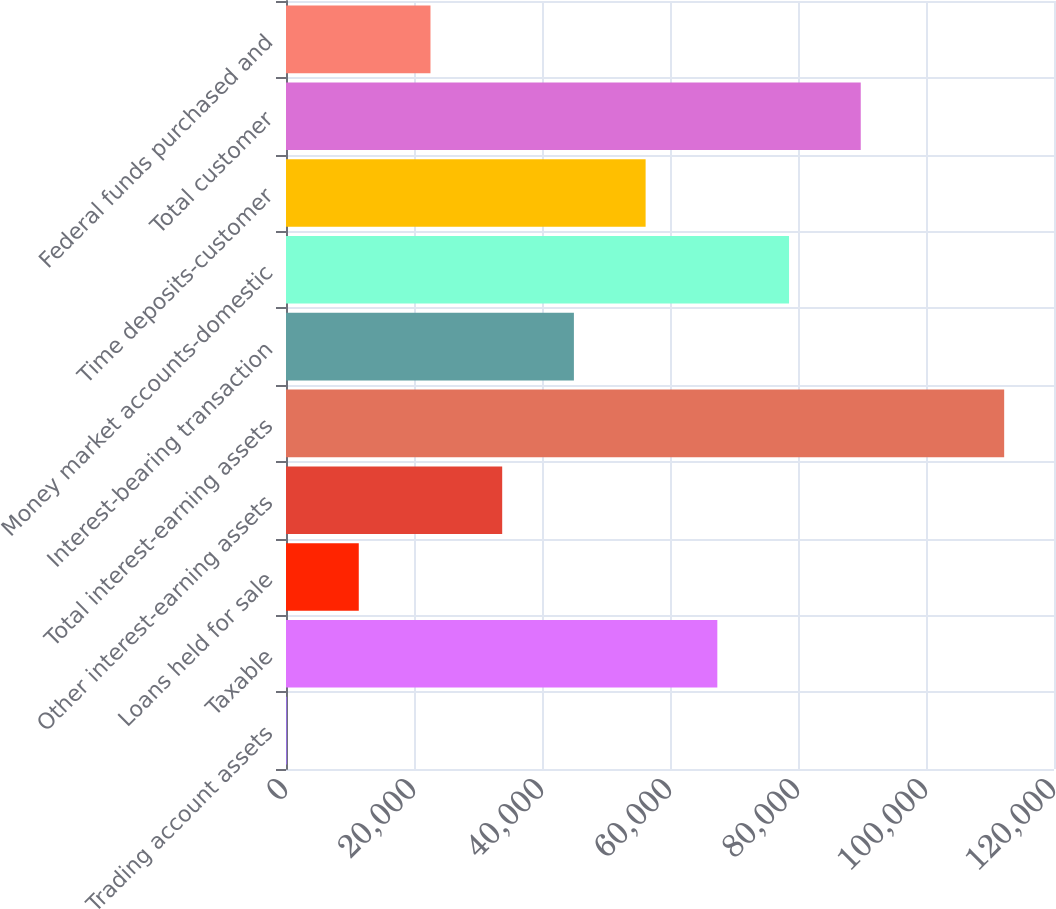Convert chart. <chart><loc_0><loc_0><loc_500><loc_500><bar_chart><fcel>Trading account assets<fcel>Taxable<fcel>Loans held for sale<fcel>Other interest-earning assets<fcel>Total interest-earning assets<fcel>Interest-bearing transaction<fcel>Money market accounts-domestic<fcel>Time deposits-customer<fcel>Total customer<fcel>Federal funds purchased and<nl><fcel>166<fcel>67394.8<fcel>11370.8<fcel>33780.4<fcel>112214<fcel>44985.2<fcel>78599.6<fcel>56190<fcel>89804.4<fcel>22575.6<nl></chart> 